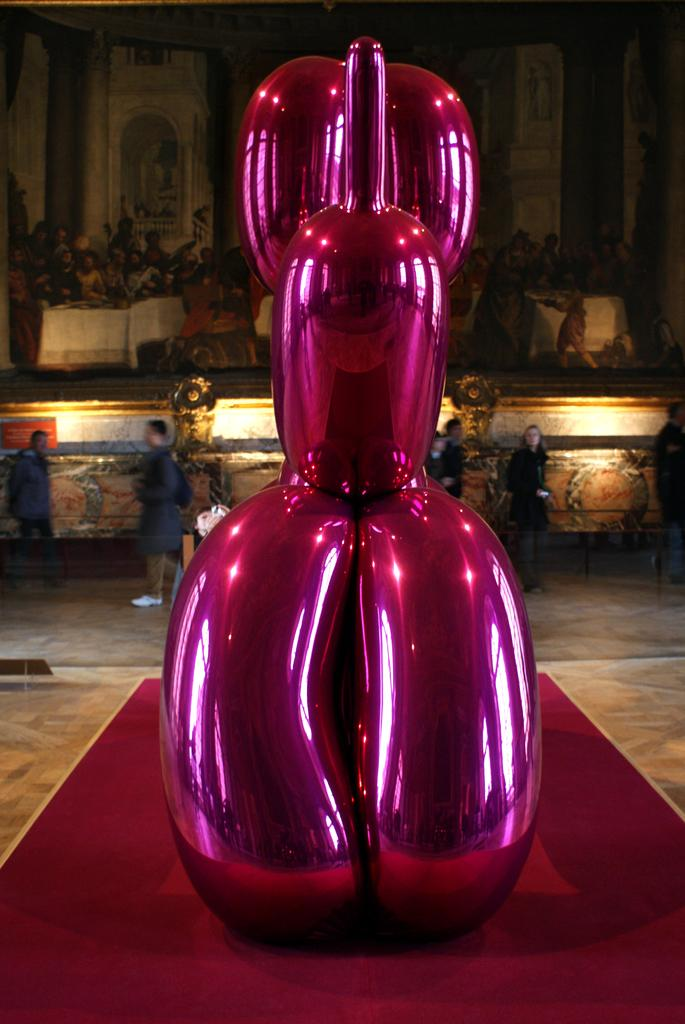What is the main subject of the image? There is a pink sculpture in the image. Can you describe the surroundings of the sculpture? There are people visible in the background of the image. What else can be seen in the background? There is a photo frame in the background of the image. How many legs can be seen on the boat in the image? There is no boat present in the image, so it is not possible to determine the number of legs on a boat. 